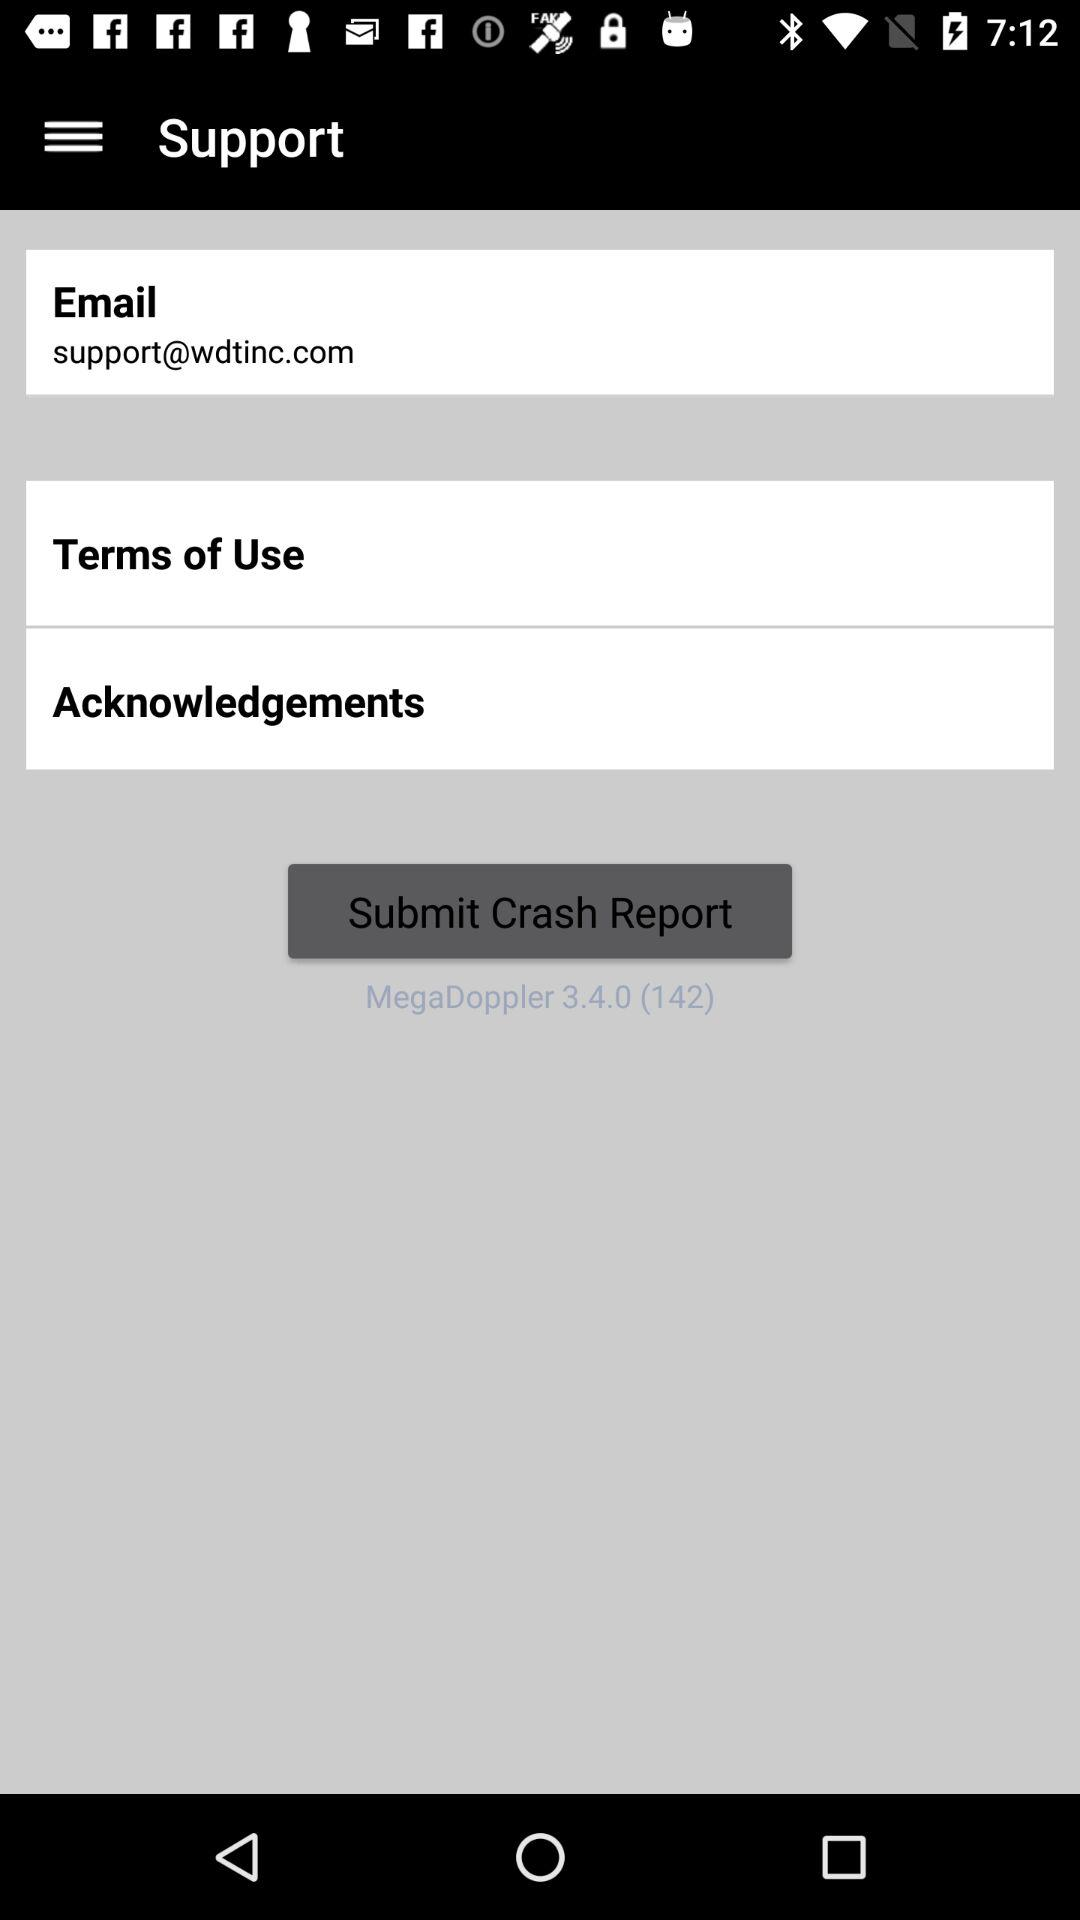What is the email address? The email address is "support@wdtinc.com". 